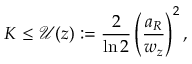Convert formula to latex. <formula><loc_0><loc_0><loc_500><loc_500>K \leq \mathcal { U } ( z ) \colon = \frac { 2 } { \ln 2 } \left ( \frac { a _ { R } } { w _ { z } } \right ) ^ { 2 } ,</formula> 